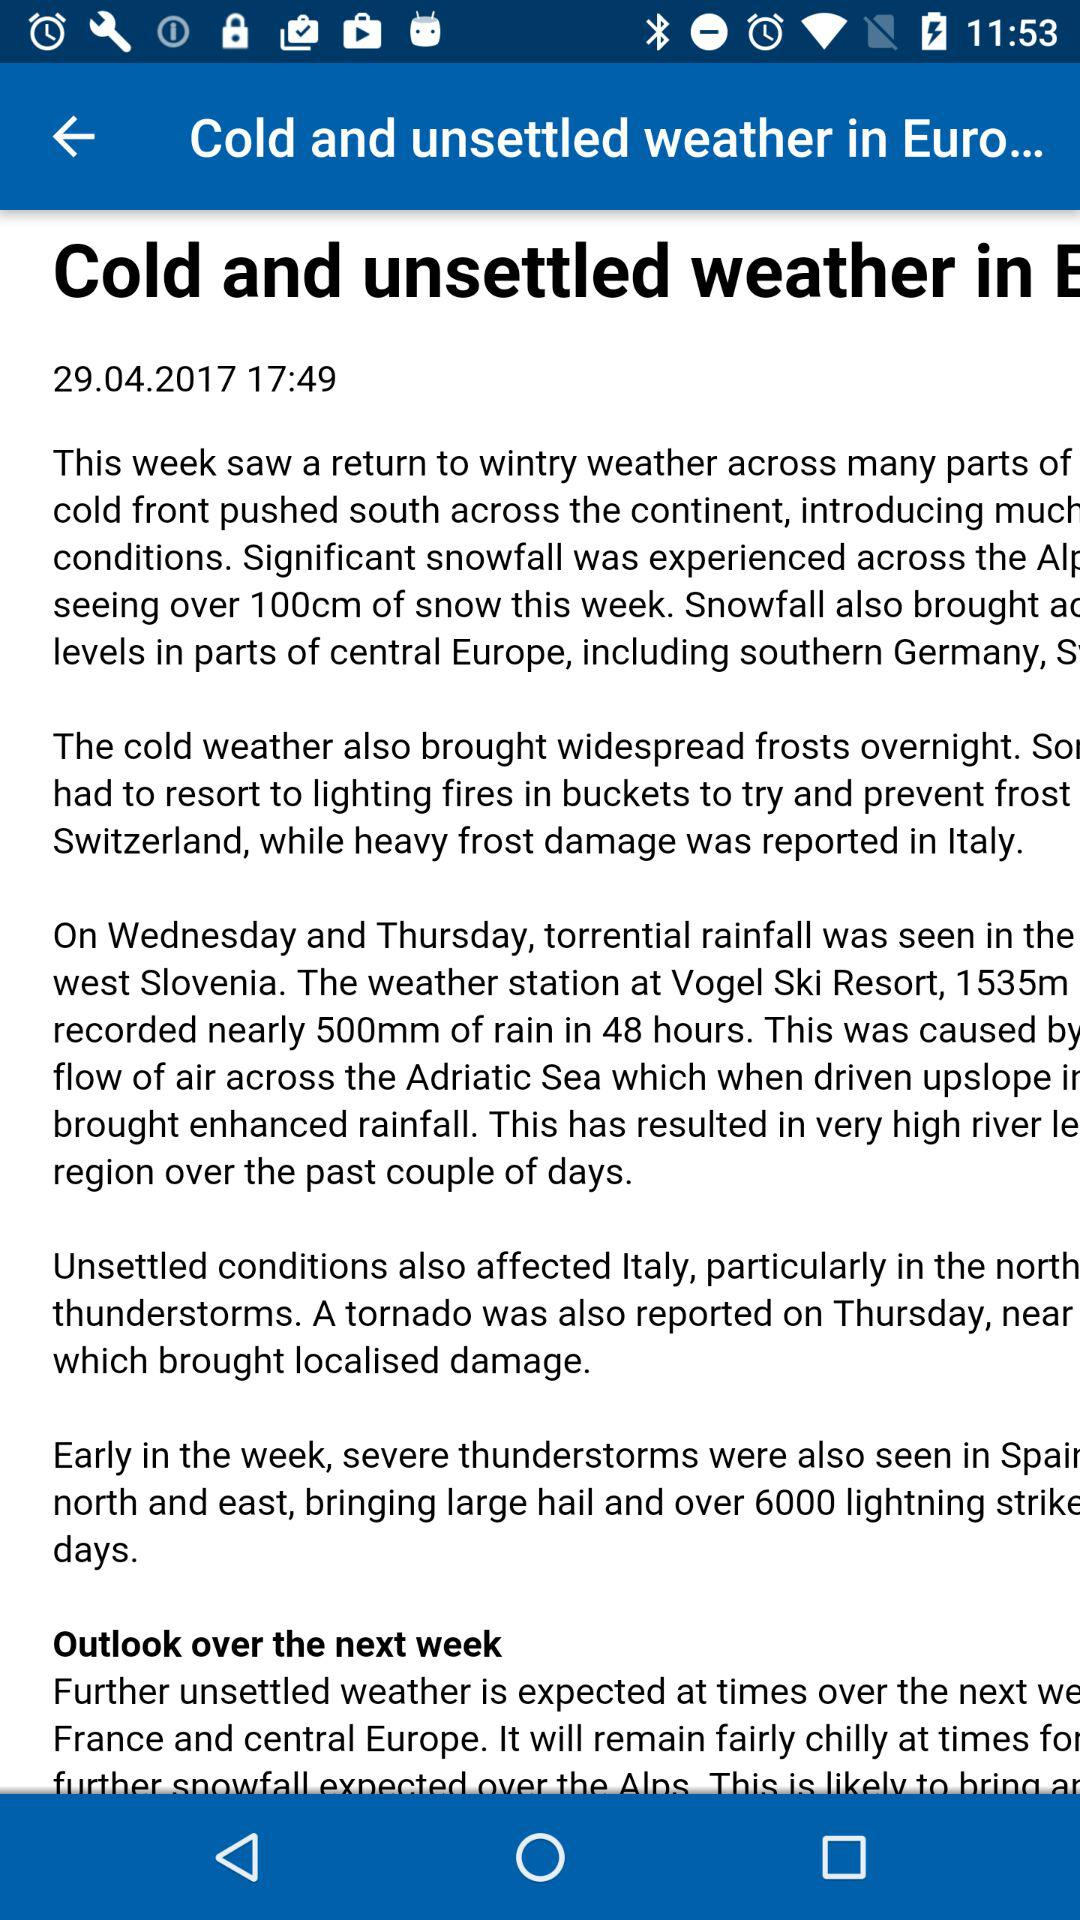At what time was the article published? The article was published at 17:49. 